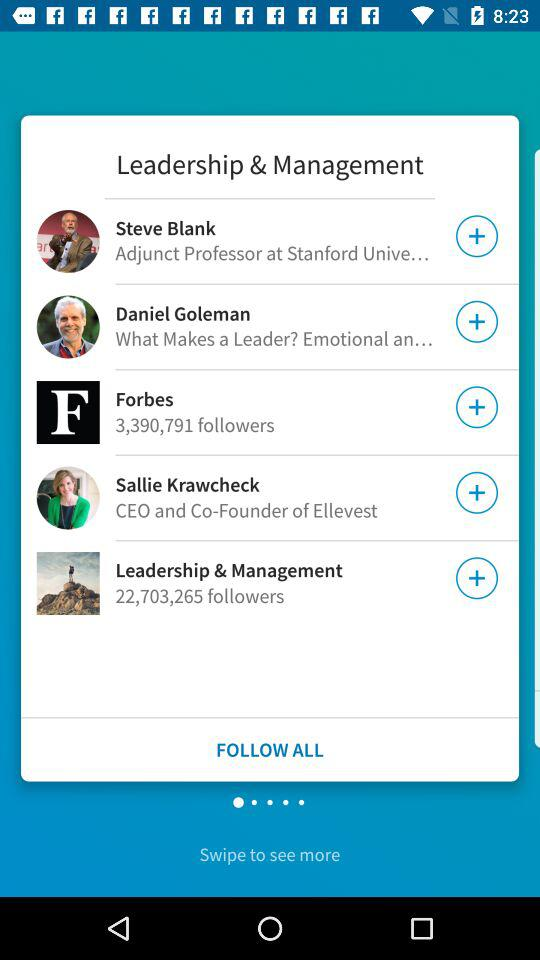How many followers does the person with the most followers have?
Answer the question using a single word or phrase. 22,703,265 